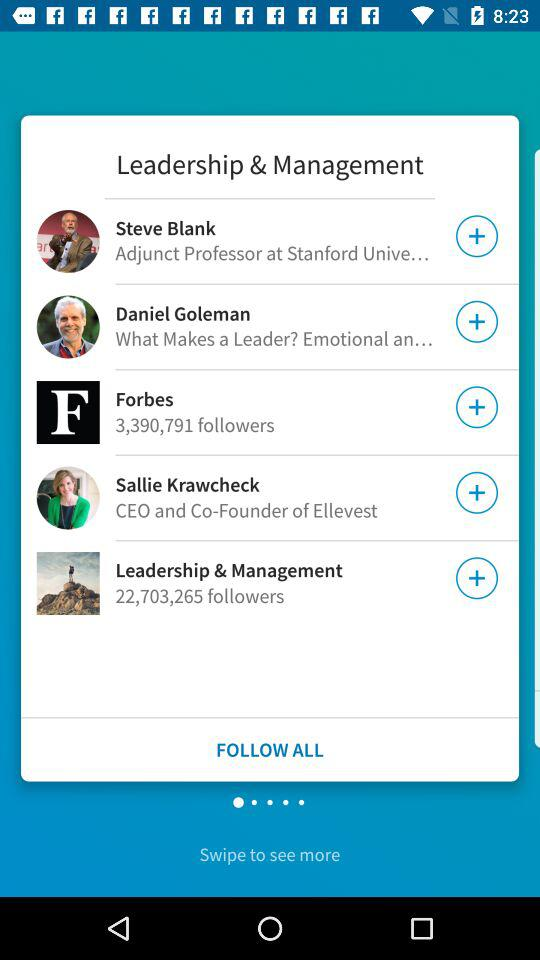How many followers does the person with the most followers have?
Answer the question using a single word or phrase. 22,703,265 